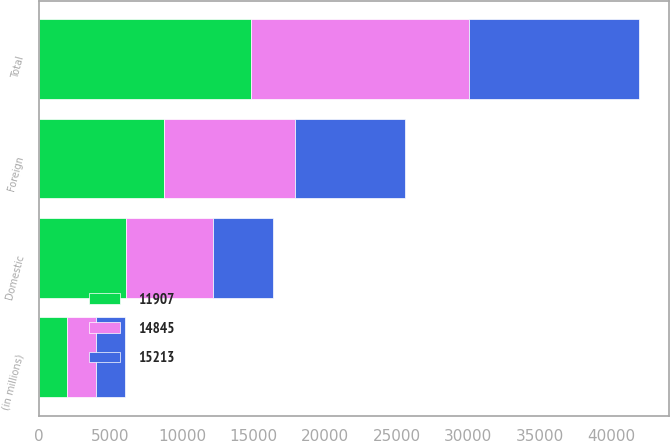Convert chart. <chart><loc_0><loc_0><loc_500><loc_500><stacked_bar_chart><ecel><fcel>(in millions)<fcel>Domestic<fcel>Foreign<fcel>Total<nl><fcel>14845<fcel>2005<fcel>6103<fcel>9110<fcel>15213<nl><fcel>11907<fcel>2004<fcel>6069<fcel>8776<fcel>14845<nl><fcel>15213<fcel>2003<fcel>4177<fcel>7730<fcel>11907<nl></chart> 